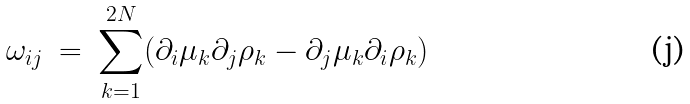Convert formula to latex. <formula><loc_0><loc_0><loc_500><loc_500>\omega _ { i j } \ = \ \sum _ { k = 1 } ^ { 2 N } ( \partial _ { i } \mu _ { k } \partial _ { j } \rho _ { k } - \partial _ { j } \mu _ { k } \partial _ { i } \rho _ { k } )</formula> 